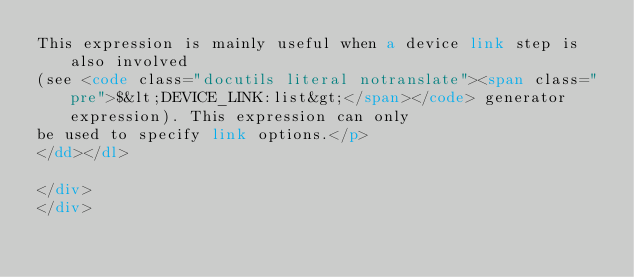<code> <loc_0><loc_0><loc_500><loc_500><_HTML_>This expression is mainly useful when a device link step is also involved
(see <code class="docutils literal notranslate"><span class="pre">$&lt;DEVICE_LINK:list&gt;</span></code> generator expression). This expression can only
be used to specify link options.</p>
</dd></dl>

</div>
</div></code> 